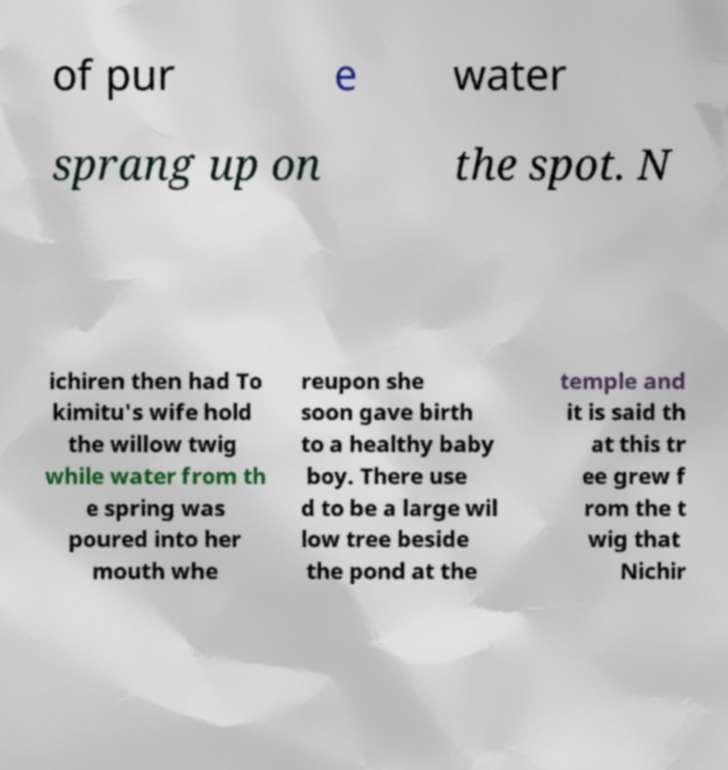There's text embedded in this image that I need extracted. Can you transcribe it verbatim? of pur e water sprang up on the spot. N ichiren then had To kimitu's wife hold the willow twig while water from th e spring was poured into her mouth whe reupon she soon gave birth to a healthy baby boy. There use d to be a large wil low tree beside the pond at the temple and it is said th at this tr ee grew f rom the t wig that Nichir 